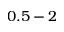Convert formula to latex. <formula><loc_0><loc_0><loc_500><loc_500>0 . 5 - 2</formula> 